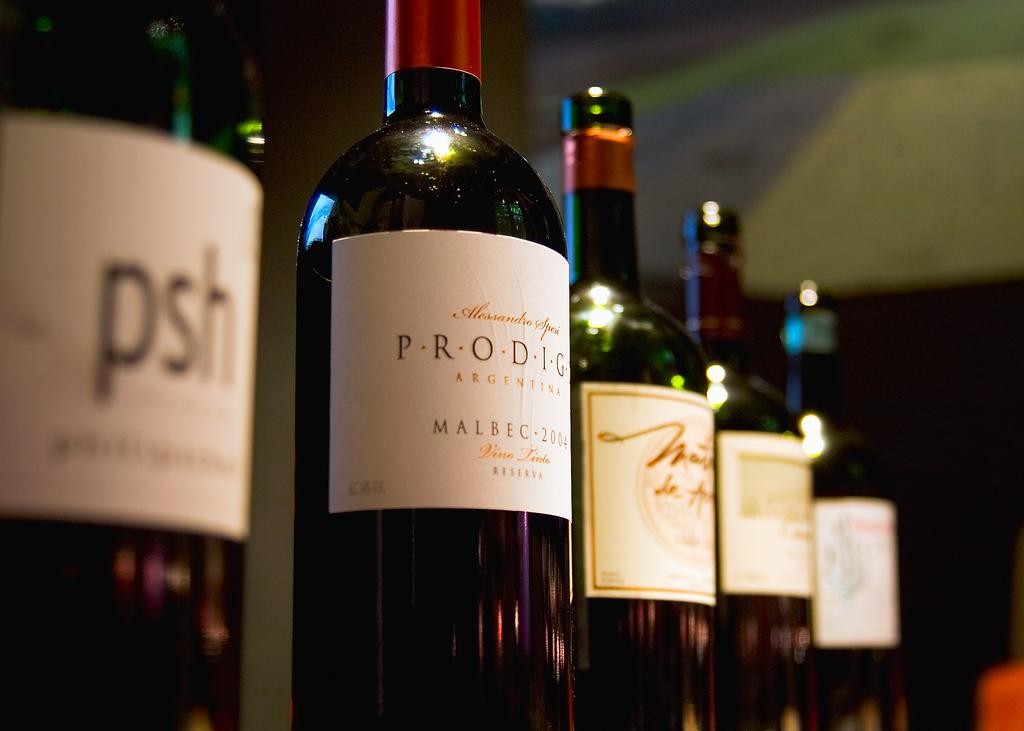<image>
Summarize the visual content of the image. A bottle of Prodigy Malbec is one in a line of wine bottles. 